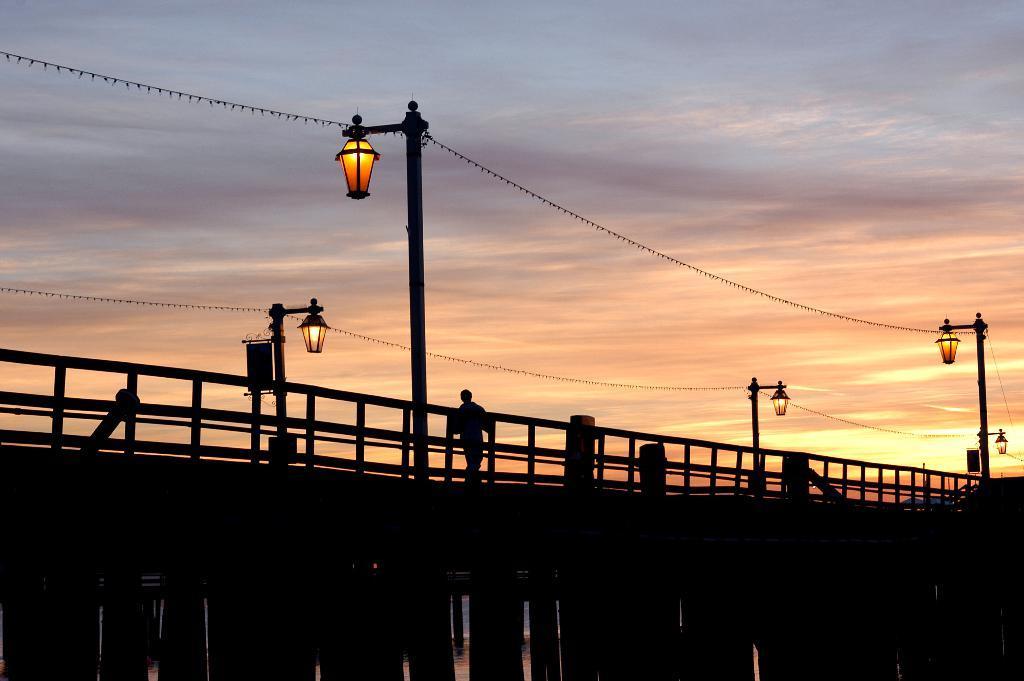In one or two sentences, can you explain what this image depicts? In this image we can see a person walking on the bridge. We can also see some wires to the street lights. On the backside we can see the sky which looks cloudy. 